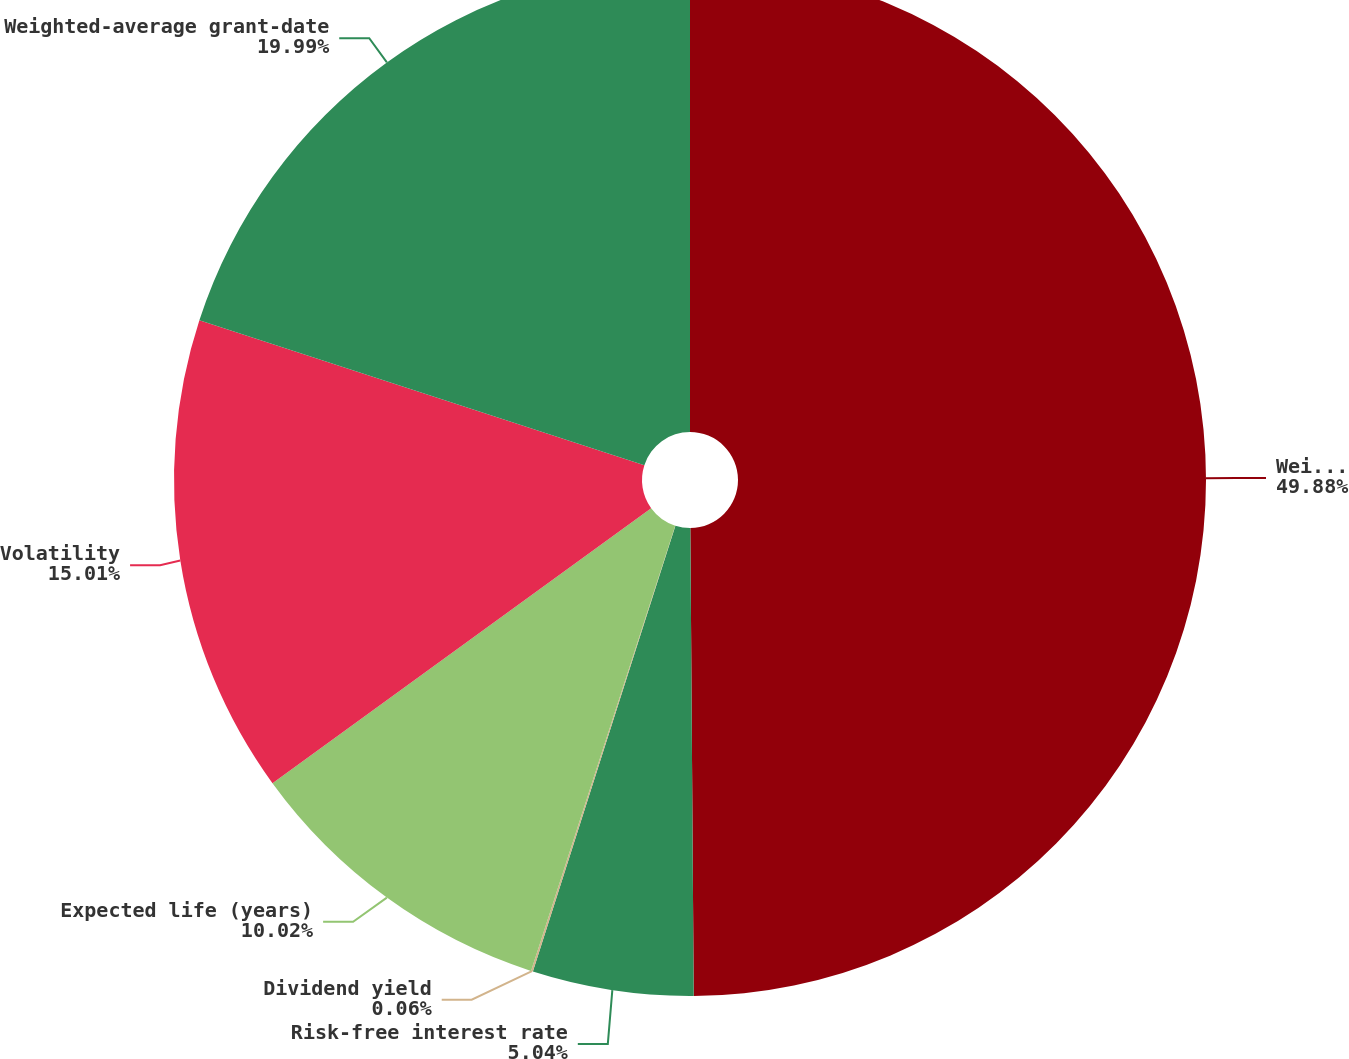<chart> <loc_0><loc_0><loc_500><loc_500><pie_chart><fcel>Weighted-Average Assumptions<fcel>Risk-free interest rate<fcel>Dividend yield<fcel>Expected life (years)<fcel>Volatility<fcel>Weighted-average grant-date<nl><fcel>49.89%<fcel>5.04%<fcel>0.06%<fcel>10.02%<fcel>15.01%<fcel>19.99%<nl></chart> 